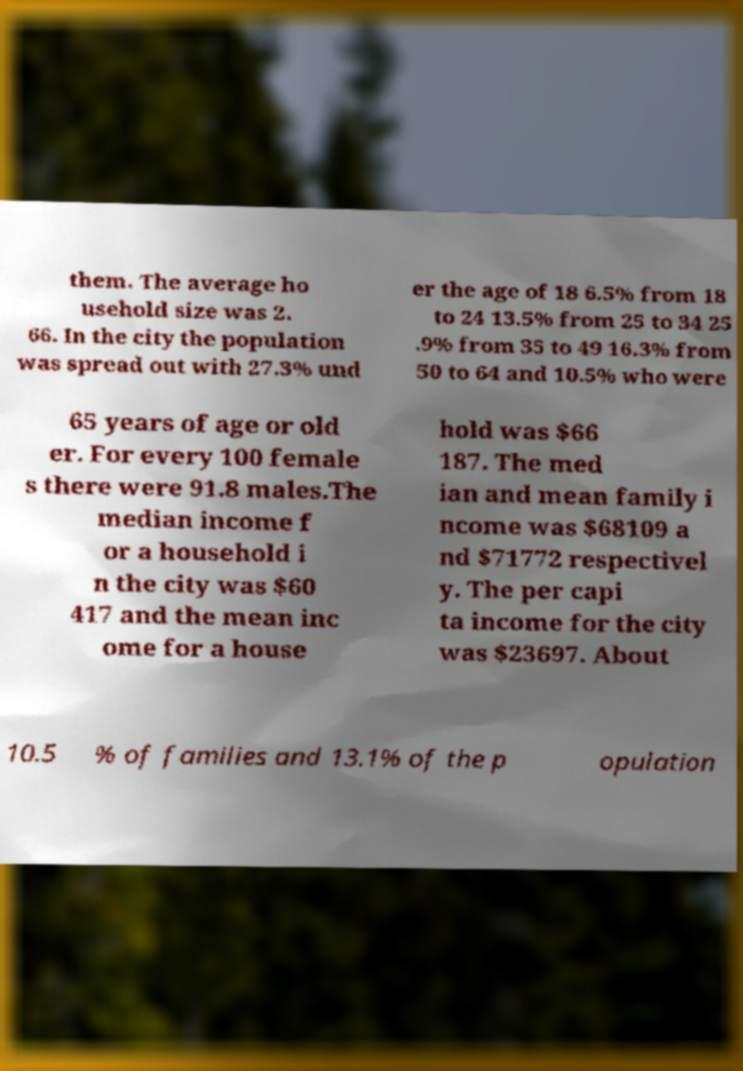I need the written content from this picture converted into text. Can you do that? them. The average ho usehold size was 2. 66. In the city the population was spread out with 27.3% und er the age of 18 6.5% from 18 to 24 13.5% from 25 to 34 25 .9% from 35 to 49 16.3% from 50 to 64 and 10.5% who were 65 years of age or old er. For every 100 female s there were 91.8 males.The median income f or a household i n the city was $60 417 and the mean inc ome for a house hold was $66 187. The med ian and mean family i ncome was $68109 a nd $71772 respectivel y. The per capi ta income for the city was $23697. About 10.5 % of families and 13.1% of the p opulation 